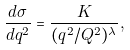<formula> <loc_0><loc_0><loc_500><loc_500>\frac { d \sigma } { d q ^ { 2 } } = \frac { K } { ( q ^ { 2 } / Q ^ { 2 } ) ^ { \lambda } } ,</formula> 